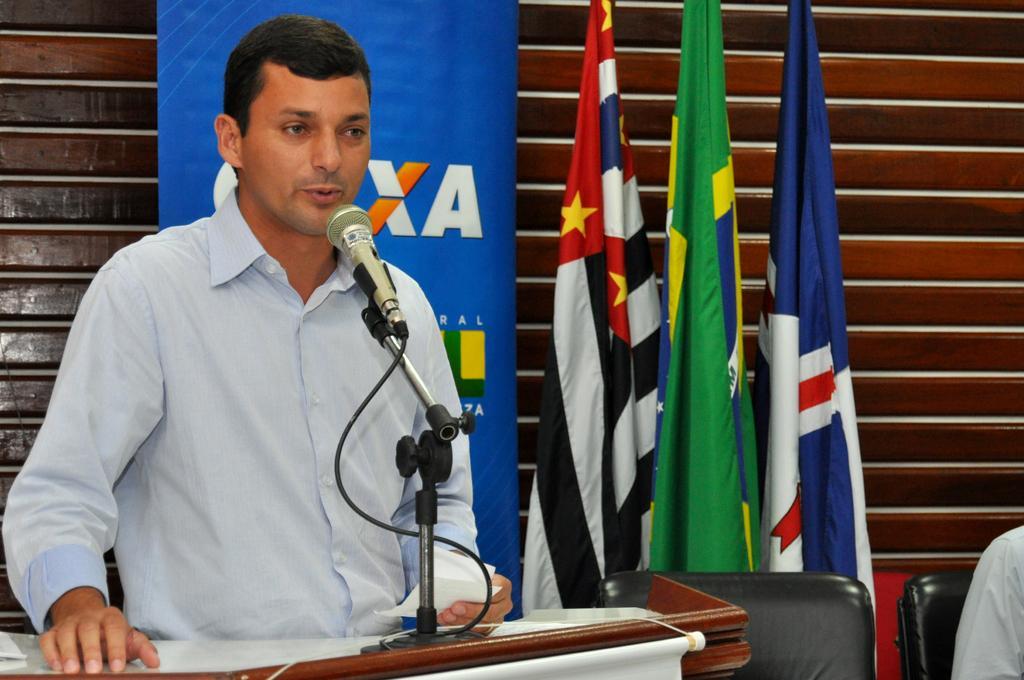Describe this image in one or two sentences. This picture shows a man standing at a podium and speaking with the help of a microphone and we see flags and a advertisement banner on the back and we see a empty chair and another woman seated on the side. 